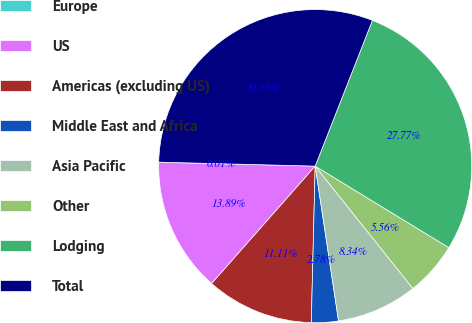Convert chart. <chart><loc_0><loc_0><loc_500><loc_500><pie_chart><fcel>Europe<fcel>US<fcel>Americas (excluding US)<fcel>Middle East and Africa<fcel>Asia Pacific<fcel>Other<fcel>Lodging<fcel>Total<nl><fcel>0.01%<fcel>13.89%<fcel>11.11%<fcel>2.78%<fcel>8.34%<fcel>5.56%<fcel>27.77%<fcel>30.55%<nl></chart> 